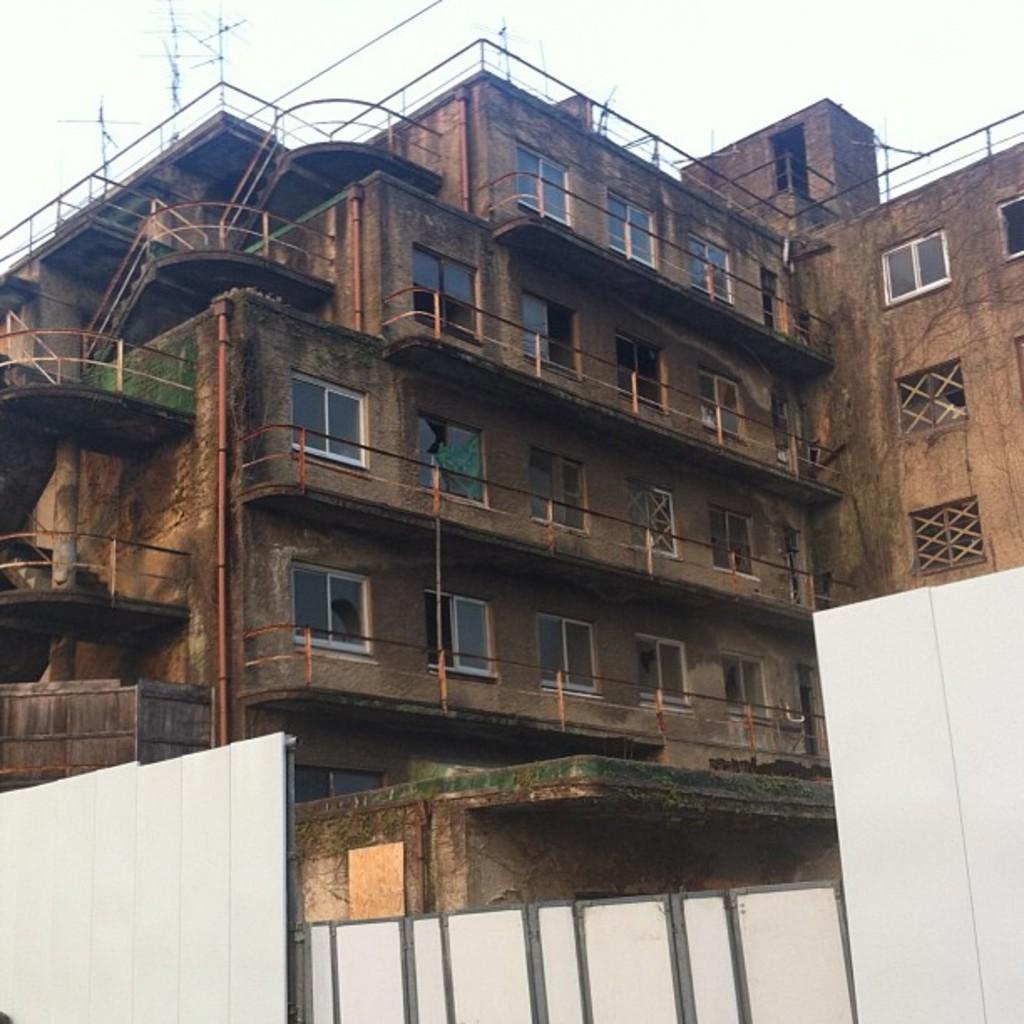Describe this image in one or two sentences. In this image we can see building with windows. At the bottom of the image there is gate. There is fencing. At the top of the image there is sky. 